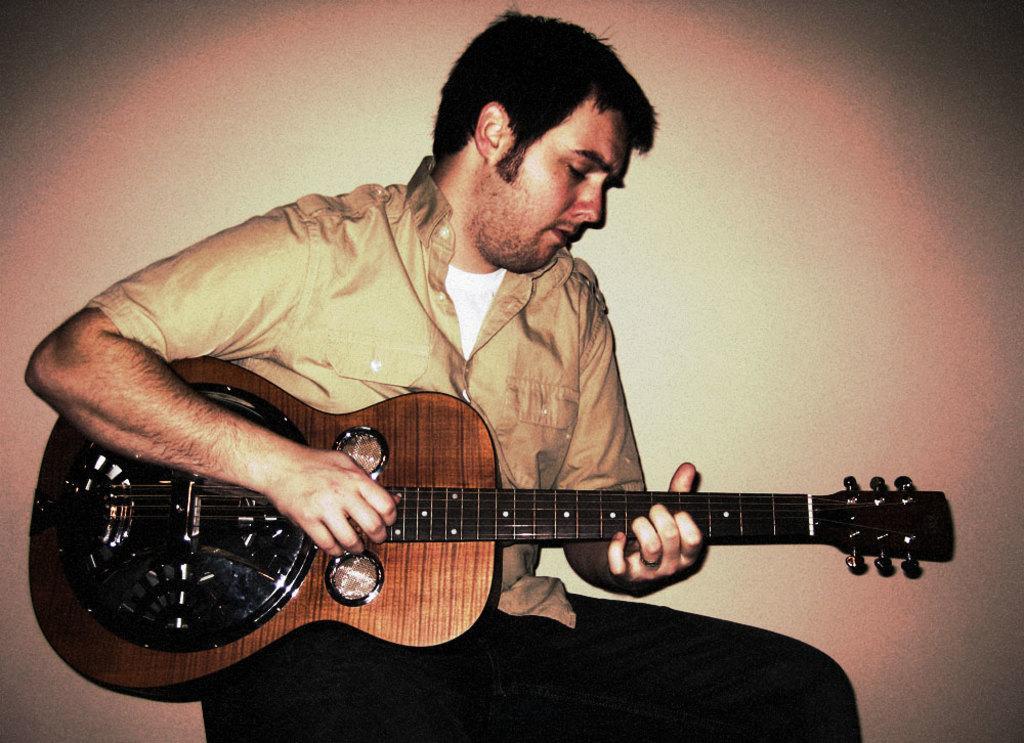How would you summarize this image in a sentence or two? This man is sitting and playing this musical instrument. 